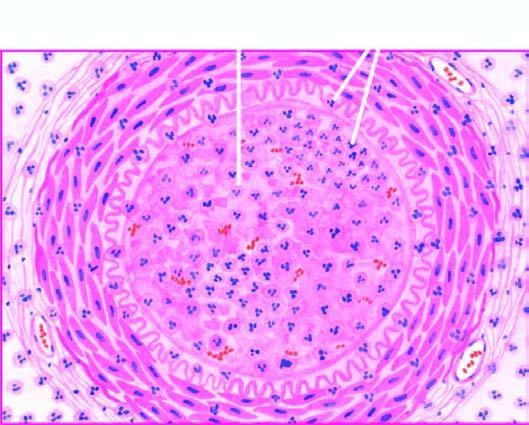what is the lumen occluded by?
Answer the question using a single word or phrase. A thrombus containing microabscesses 